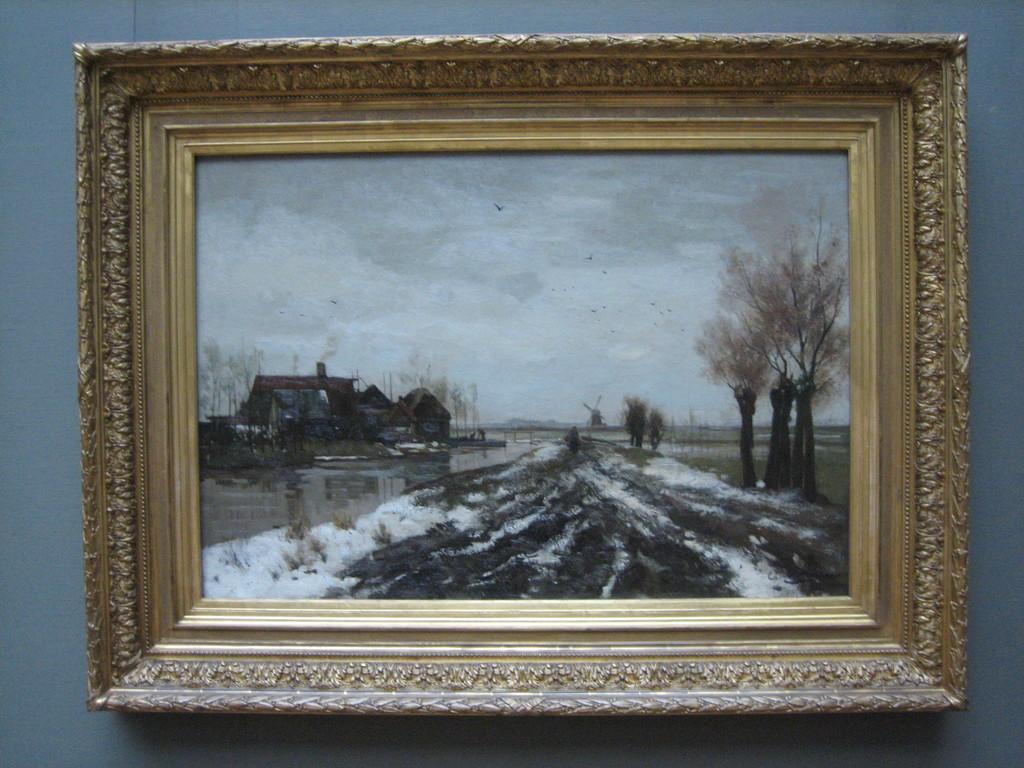In one or two sentences, can you explain what this image depicts? This image consists of a photo frame hanged on the wall. In the photo frame we can see a house and trees along with the snow. 